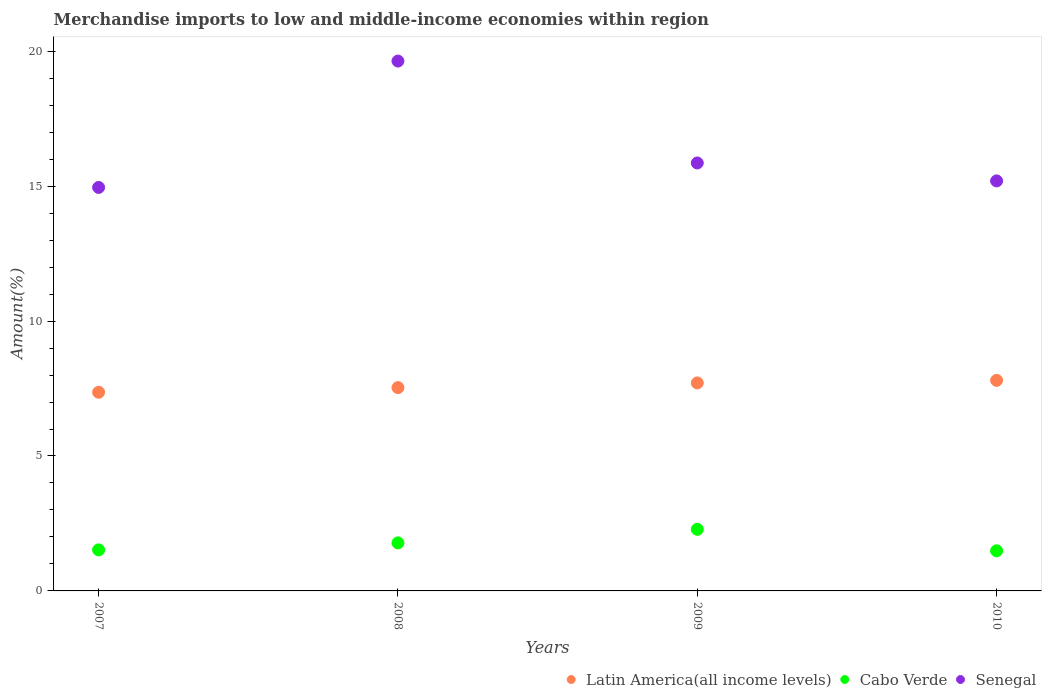How many different coloured dotlines are there?
Your answer should be compact. 3. What is the percentage of amount earned from merchandise imports in Cabo Verde in 2009?
Provide a succinct answer. 2.28. Across all years, what is the maximum percentage of amount earned from merchandise imports in Senegal?
Provide a short and direct response. 19.64. Across all years, what is the minimum percentage of amount earned from merchandise imports in Senegal?
Keep it short and to the point. 14.95. What is the total percentage of amount earned from merchandise imports in Senegal in the graph?
Your response must be concise. 65.64. What is the difference between the percentage of amount earned from merchandise imports in Latin America(all income levels) in 2008 and that in 2009?
Provide a short and direct response. -0.17. What is the difference between the percentage of amount earned from merchandise imports in Senegal in 2008 and the percentage of amount earned from merchandise imports in Cabo Verde in 2009?
Ensure brevity in your answer.  17.35. What is the average percentage of amount earned from merchandise imports in Latin America(all income levels) per year?
Your answer should be very brief. 7.6. In the year 2007, what is the difference between the percentage of amount earned from merchandise imports in Senegal and percentage of amount earned from merchandise imports in Latin America(all income levels)?
Ensure brevity in your answer.  7.59. What is the ratio of the percentage of amount earned from merchandise imports in Senegal in 2009 to that in 2010?
Offer a very short reply. 1.04. Is the difference between the percentage of amount earned from merchandise imports in Senegal in 2009 and 2010 greater than the difference between the percentage of amount earned from merchandise imports in Latin America(all income levels) in 2009 and 2010?
Offer a terse response. Yes. What is the difference between the highest and the second highest percentage of amount earned from merchandise imports in Cabo Verde?
Provide a succinct answer. 0.5. What is the difference between the highest and the lowest percentage of amount earned from merchandise imports in Cabo Verde?
Offer a very short reply. 0.8. Does the percentage of amount earned from merchandise imports in Latin America(all income levels) monotonically increase over the years?
Your answer should be very brief. Yes. Is the percentage of amount earned from merchandise imports in Cabo Verde strictly less than the percentage of amount earned from merchandise imports in Senegal over the years?
Offer a terse response. Yes. How many dotlines are there?
Provide a succinct answer. 3. How are the legend labels stacked?
Your answer should be compact. Horizontal. What is the title of the graph?
Your answer should be very brief. Merchandise imports to low and middle-income economies within region. Does "Tanzania" appear as one of the legend labels in the graph?
Provide a succinct answer. No. What is the label or title of the Y-axis?
Your answer should be very brief. Amount(%). What is the Amount(%) of Latin America(all income levels) in 2007?
Offer a terse response. 7.36. What is the Amount(%) of Cabo Verde in 2007?
Make the answer very short. 1.52. What is the Amount(%) of Senegal in 2007?
Offer a very short reply. 14.95. What is the Amount(%) of Latin America(all income levels) in 2008?
Offer a terse response. 7.53. What is the Amount(%) of Cabo Verde in 2008?
Your answer should be compact. 1.78. What is the Amount(%) of Senegal in 2008?
Provide a short and direct response. 19.64. What is the Amount(%) in Latin America(all income levels) in 2009?
Provide a short and direct response. 7.71. What is the Amount(%) in Cabo Verde in 2009?
Offer a terse response. 2.28. What is the Amount(%) in Senegal in 2009?
Give a very brief answer. 15.86. What is the Amount(%) of Latin America(all income levels) in 2010?
Make the answer very short. 7.8. What is the Amount(%) of Cabo Verde in 2010?
Offer a terse response. 1.49. What is the Amount(%) in Senegal in 2010?
Offer a very short reply. 15.19. Across all years, what is the maximum Amount(%) of Latin America(all income levels)?
Your response must be concise. 7.8. Across all years, what is the maximum Amount(%) of Cabo Verde?
Give a very brief answer. 2.28. Across all years, what is the maximum Amount(%) of Senegal?
Your response must be concise. 19.64. Across all years, what is the minimum Amount(%) in Latin America(all income levels)?
Offer a terse response. 7.36. Across all years, what is the minimum Amount(%) of Cabo Verde?
Give a very brief answer. 1.49. Across all years, what is the minimum Amount(%) of Senegal?
Provide a short and direct response. 14.95. What is the total Amount(%) in Latin America(all income levels) in the graph?
Keep it short and to the point. 30.41. What is the total Amount(%) of Cabo Verde in the graph?
Offer a terse response. 7.07. What is the total Amount(%) in Senegal in the graph?
Your answer should be very brief. 65.64. What is the difference between the Amount(%) of Latin America(all income levels) in 2007 and that in 2008?
Provide a short and direct response. -0.17. What is the difference between the Amount(%) in Cabo Verde in 2007 and that in 2008?
Keep it short and to the point. -0.26. What is the difference between the Amount(%) of Senegal in 2007 and that in 2008?
Make the answer very short. -4.68. What is the difference between the Amount(%) of Latin America(all income levels) in 2007 and that in 2009?
Provide a short and direct response. -0.35. What is the difference between the Amount(%) in Cabo Verde in 2007 and that in 2009?
Offer a very short reply. -0.76. What is the difference between the Amount(%) of Senegal in 2007 and that in 2009?
Your response must be concise. -0.91. What is the difference between the Amount(%) in Latin America(all income levels) in 2007 and that in 2010?
Your answer should be very brief. -0.44. What is the difference between the Amount(%) in Cabo Verde in 2007 and that in 2010?
Offer a very short reply. 0.03. What is the difference between the Amount(%) of Senegal in 2007 and that in 2010?
Your answer should be compact. -0.24. What is the difference between the Amount(%) in Latin America(all income levels) in 2008 and that in 2009?
Make the answer very short. -0.17. What is the difference between the Amount(%) in Cabo Verde in 2008 and that in 2009?
Provide a short and direct response. -0.5. What is the difference between the Amount(%) of Senegal in 2008 and that in 2009?
Provide a succinct answer. 3.78. What is the difference between the Amount(%) in Latin America(all income levels) in 2008 and that in 2010?
Provide a succinct answer. -0.27. What is the difference between the Amount(%) in Cabo Verde in 2008 and that in 2010?
Give a very brief answer. 0.29. What is the difference between the Amount(%) of Senegal in 2008 and that in 2010?
Provide a succinct answer. 4.44. What is the difference between the Amount(%) in Latin America(all income levels) in 2009 and that in 2010?
Ensure brevity in your answer.  -0.09. What is the difference between the Amount(%) of Cabo Verde in 2009 and that in 2010?
Your response must be concise. 0.8. What is the difference between the Amount(%) in Senegal in 2009 and that in 2010?
Provide a short and direct response. 0.66. What is the difference between the Amount(%) in Latin America(all income levels) in 2007 and the Amount(%) in Cabo Verde in 2008?
Offer a very short reply. 5.58. What is the difference between the Amount(%) of Latin America(all income levels) in 2007 and the Amount(%) of Senegal in 2008?
Keep it short and to the point. -12.27. What is the difference between the Amount(%) in Cabo Verde in 2007 and the Amount(%) in Senegal in 2008?
Offer a very short reply. -18.12. What is the difference between the Amount(%) in Latin America(all income levels) in 2007 and the Amount(%) in Cabo Verde in 2009?
Keep it short and to the point. 5.08. What is the difference between the Amount(%) of Latin America(all income levels) in 2007 and the Amount(%) of Senegal in 2009?
Ensure brevity in your answer.  -8.5. What is the difference between the Amount(%) of Cabo Verde in 2007 and the Amount(%) of Senegal in 2009?
Your response must be concise. -14.34. What is the difference between the Amount(%) in Latin America(all income levels) in 2007 and the Amount(%) in Cabo Verde in 2010?
Your answer should be very brief. 5.88. What is the difference between the Amount(%) of Latin America(all income levels) in 2007 and the Amount(%) of Senegal in 2010?
Give a very brief answer. -7.83. What is the difference between the Amount(%) in Cabo Verde in 2007 and the Amount(%) in Senegal in 2010?
Make the answer very short. -13.67. What is the difference between the Amount(%) of Latin America(all income levels) in 2008 and the Amount(%) of Cabo Verde in 2009?
Ensure brevity in your answer.  5.25. What is the difference between the Amount(%) of Latin America(all income levels) in 2008 and the Amount(%) of Senegal in 2009?
Offer a terse response. -8.32. What is the difference between the Amount(%) of Cabo Verde in 2008 and the Amount(%) of Senegal in 2009?
Your answer should be compact. -14.08. What is the difference between the Amount(%) in Latin America(all income levels) in 2008 and the Amount(%) in Cabo Verde in 2010?
Your answer should be very brief. 6.05. What is the difference between the Amount(%) in Latin America(all income levels) in 2008 and the Amount(%) in Senegal in 2010?
Keep it short and to the point. -7.66. What is the difference between the Amount(%) of Cabo Verde in 2008 and the Amount(%) of Senegal in 2010?
Ensure brevity in your answer.  -13.41. What is the difference between the Amount(%) of Latin America(all income levels) in 2009 and the Amount(%) of Cabo Verde in 2010?
Provide a short and direct response. 6.22. What is the difference between the Amount(%) in Latin America(all income levels) in 2009 and the Amount(%) in Senegal in 2010?
Give a very brief answer. -7.49. What is the difference between the Amount(%) of Cabo Verde in 2009 and the Amount(%) of Senegal in 2010?
Your response must be concise. -12.91. What is the average Amount(%) of Latin America(all income levels) per year?
Your answer should be very brief. 7.6. What is the average Amount(%) of Cabo Verde per year?
Offer a terse response. 1.77. What is the average Amount(%) in Senegal per year?
Offer a terse response. 16.41. In the year 2007, what is the difference between the Amount(%) of Latin America(all income levels) and Amount(%) of Cabo Verde?
Provide a short and direct response. 5.84. In the year 2007, what is the difference between the Amount(%) of Latin America(all income levels) and Amount(%) of Senegal?
Provide a short and direct response. -7.59. In the year 2007, what is the difference between the Amount(%) of Cabo Verde and Amount(%) of Senegal?
Offer a terse response. -13.43. In the year 2008, what is the difference between the Amount(%) in Latin America(all income levels) and Amount(%) in Cabo Verde?
Ensure brevity in your answer.  5.75. In the year 2008, what is the difference between the Amount(%) in Latin America(all income levels) and Amount(%) in Senegal?
Keep it short and to the point. -12.1. In the year 2008, what is the difference between the Amount(%) of Cabo Verde and Amount(%) of Senegal?
Offer a very short reply. -17.86. In the year 2009, what is the difference between the Amount(%) in Latin America(all income levels) and Amount(%) in Cabo Verde?
Provide a short and direct response. 5.43. In the year 2009, what is the difference between the Amount(%) in Latin America(all income levels) and Amount(%) in Senegal?
Provide a succinct answer. -8.15. In the year 2009, what is the difference between the Amount(%) of Cabo Verde and Amount(%) of Senegal?
Make the answer very short. -13.58. In the year 2010, what is the difference between the Amount(%) of Latin America(all income levels) and Amount(%) of Cabo Verde?
Offer a terse response. 6.32. In the year 2010, what is the difference between the Amount(%) of Latin America(all income levels) and Amount(%) of Senegal?
Your answer should be compact. -7.39. In the year 2010, what is the difference between the Amount(%) in Cabo Verde and Amount(%) in Senegal?
Your answer should be very brief. -13.71. What is the ratio of the Amount(%) in Latin America(all income levels) in 2007 to that in 2008?
Keep it short and to the point. 0.98. What is the ratio of the Amount(%) in Cabo Verde in 2007 to that in 2008?
Your answer should be very brief. 0.85. What is the ratio of the Amount(%) in Senegal in 2007 to that in 2008?
Keep it short and to the point. 0.76. What is the ratio of the Amount(%) in Latin America(all income levels) in 2007 to that in 2009?
Keep it short and to the point. 0.95. What is the ratio of the Amount(%) in Cabo Verde in 2007 to that in 2009?
Offer a very short reply. 0.67. What is the ratio of the Amount(%) in Senegal in 2007 to that in 2009?
Make the answer very short. 0.94. What is the ratio of the Amount(%) of Latin America(all income levels) in 2007 to that in 2010?
Provide a succinct answer. 0.94. What is the ratio of the Amount(%) in Cabo Verde in 2007 to that in 2010?
Give a very brief answer. 1.02. What is the ratio of the Amount(%) in Senegal in 2007 to that in 2010?
Provide a short and direct response. 0.98. What is the ratio of the Amount(%) of Latin America(all income levels) in 2008 to that in 2009?
Your answer should be compact. 0.98. What is the ratio of the Amount(%) of Cabo Verde in 2008 to that in 2009?
Offer a terse response. 0.78. What is the ratio of the Amount(%) in Senegal in 2008 to that in 2009?
Ensure brevity in your answer.  1.24. What is the ratio of the Amount(%) of Latin America(all income levels) in 2008 to that in 2010?
Your answer should be very brief. 0.97. What is the ratio of the Amount(%) in Cabo Verde in 2008 to that in 2010?
Your response must be concise. 1.2. What is the ratio of the Amount(%) of Senegal in 2008 to that in 2010?
Offer a terse response. 1.29. What is the ratio of the Amount(%) of Cabo Verde in 2009 to that in 2010?
Give a very brief answer. 1.54. What is the ratio of the Amount(%) of Senegal in 2009 to that in 2010?
Your answer should be compact. 1.04. What is the difference between the highest and the second highest Amount(%) of Latin America(all income levels)?
Offer a very short reply. 0.09. What is the difference between the highest and the second highest Amount(%) in Cabo Verde?
Your answer should be very brief. 0.5. What is the difference between the highest and the second highest Amount(%) of Senegal?
Keep it short and to the point. 3.78. What is the difference between the highest and the lowest Amount(%) in Latin America(all income levels)?
Offer a very short reply. 0.44. What is the difference between the highest and the lowest Amount(%) of Cabo Verde?
Give a very brief answer. 0.8. What is the difference between the highest and the lowest Amount(%) in Senegal?
Make the answer very short. 4.68. 